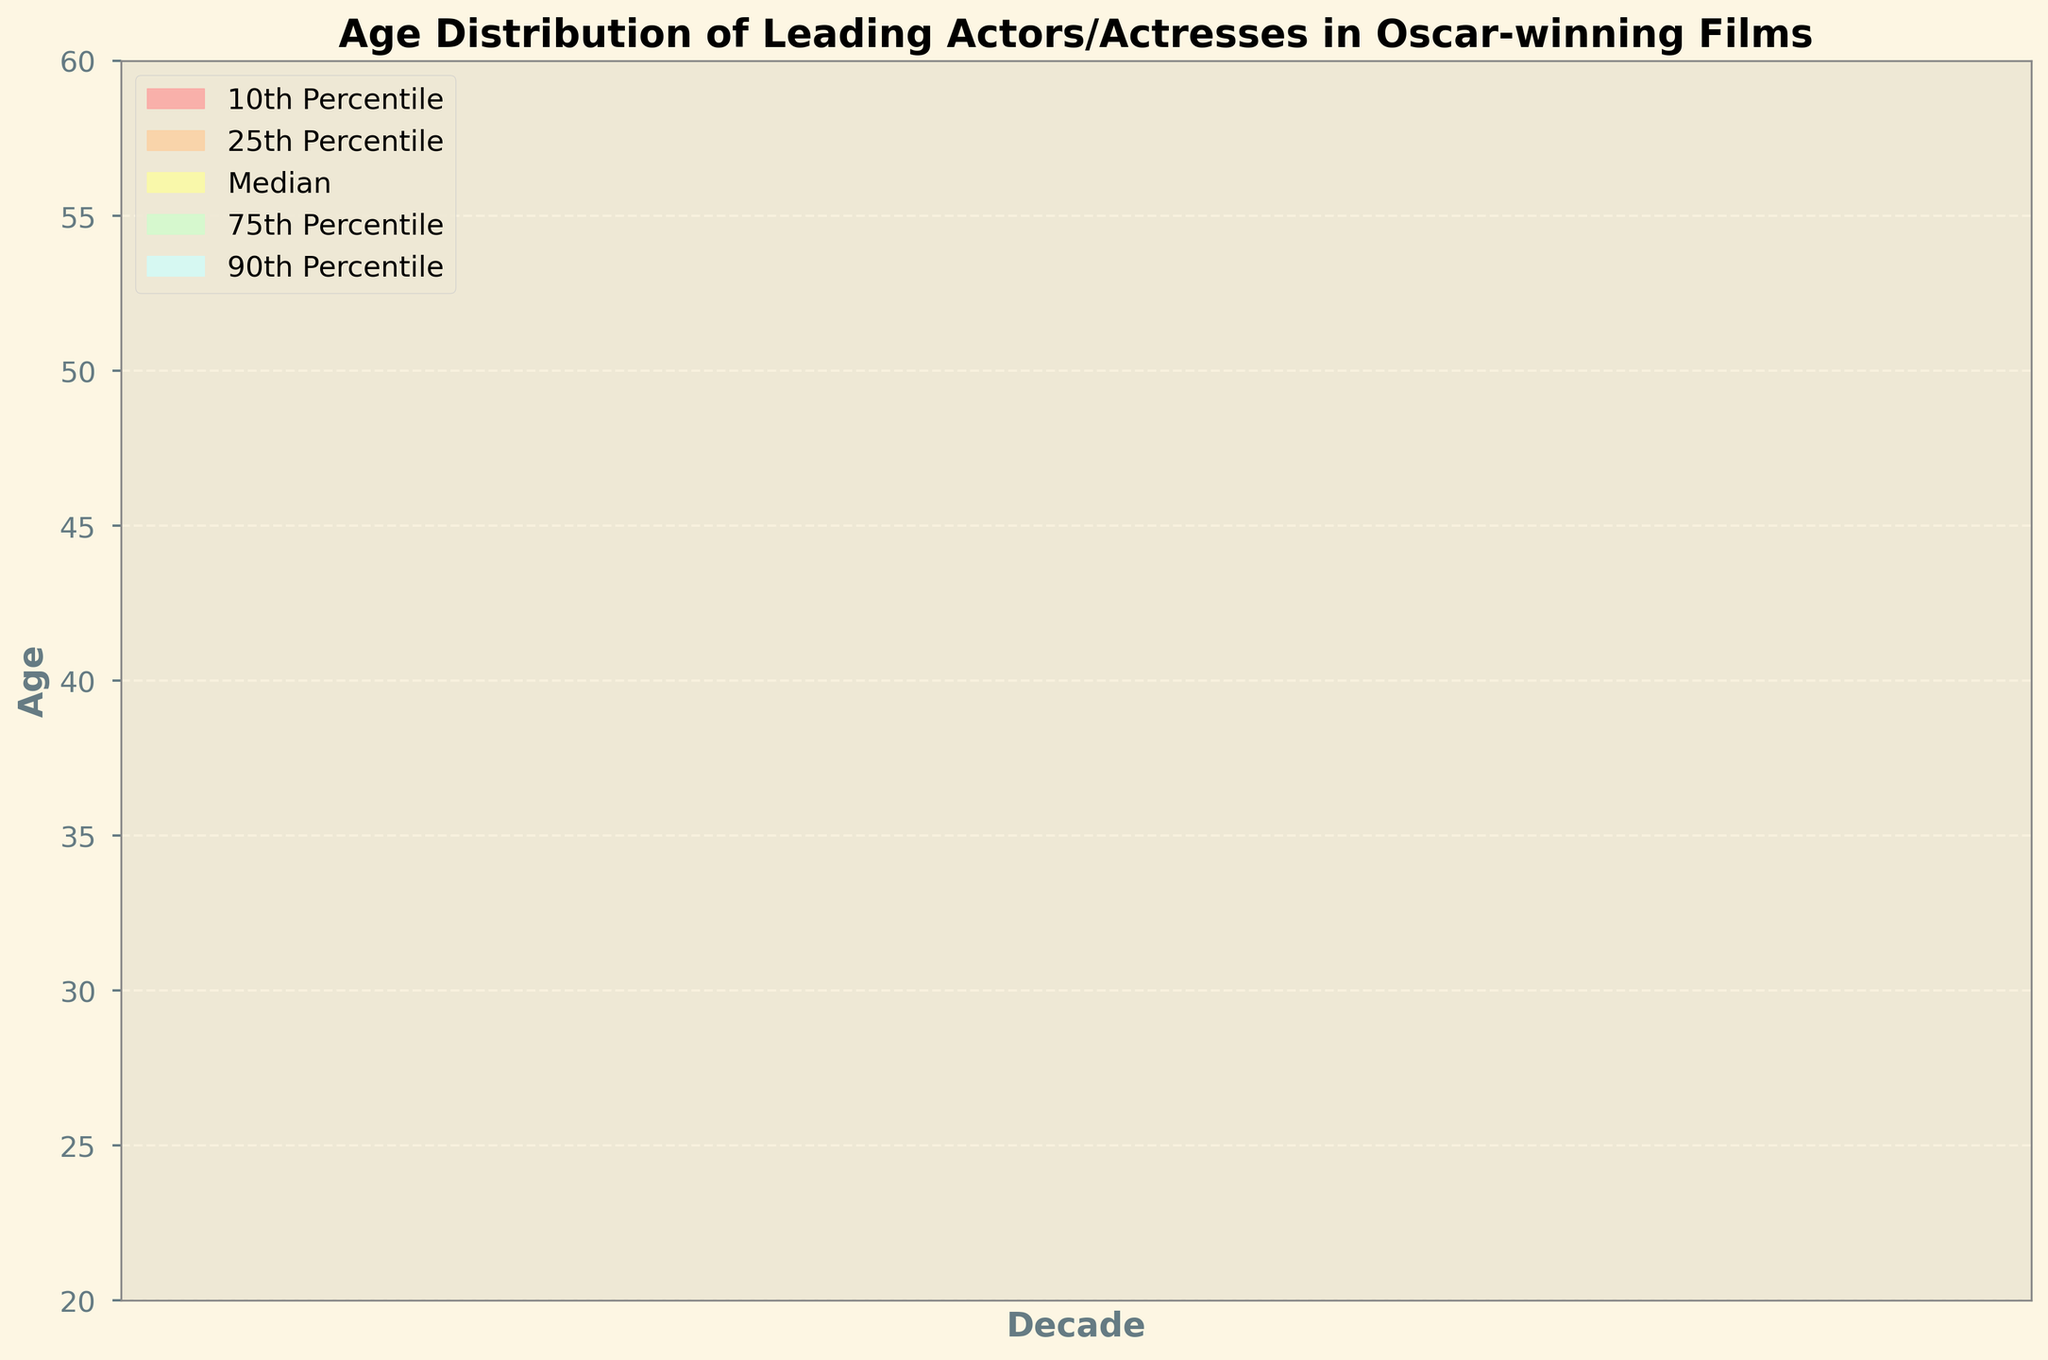What is the title of the figure? Look at the top of the plot where the title is usually displayed.
Answer: Age Distribution of Leading Actors/Actresses in Oscar-winning Films What is the median age of leading actors/actresses in the 2000-2009 decade? Locate the value corresponding to the 'Median' row for the 2000-2009 time range in the data.
Answer: 37 How has the 10th percentile age of leading actors/actresses changed from the 1990-1999 decade to the 2010-2019 decade? Compare the values from the '10th Percentile' row for the 1990-1999 and 2010-2019 time ranges. The 1990-1999 value is 26, and the 2010-2019 value is 30. Calculate the difference.
Answer: Increased by 4 years Which decade has the highest 90th percentile age? Look at the '90th Percentile' values for all three decades and determine the highest value.
Answer: 2010-2019 What is the age range between the 25th and 75th percentiles for the 2010-2019 decade? Subtract the 25th percentile value for the 2010-2019 decade from the 75th percentile value for the same decade. The values are 34 and 47, respectively.
Answer: 13 How does the median age of leading actors/actresses in the 1990-1999 decade compare to the median age in the 2010-2019 decade? Compare the 'Median' values of the two decades. The 1990-1999 value is 35, and the 2010-2019 value is 39. Determine whether the median has increased or decreased.
Answer: Increased by 4 years What are the colors used to represent the different percentiles? Observe the fill colors for different percentiles in the plot's legend.
Answer: Various shades of pink, orange, yellow, green, and blue What is the trend in the 75th percentile age over the three decades? Identify the '75th Percentile' values for each decade and observe whether they increase, decrease, or remain constant over time.
Answer: Increasing trend Which percentile shows the most significant age increase from the 1990-1999 decade to the 2010-2019 decade? Calculate the age differences for each percentile between 1990-1999 and 2010-2019, then identify the largest difference.
Answer: 90th Percentile (Increased by 5 years) How many decade intervals are shown in the figure? Count the unique time intervals represented on the x-axis.
Answer: 3 